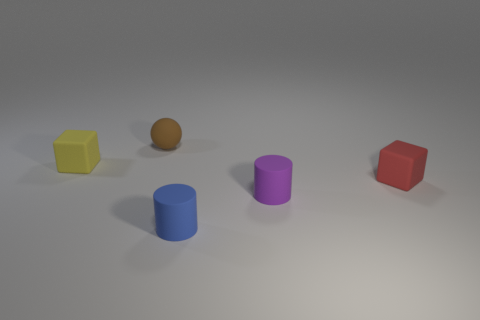There is a rubber object that is behind the block that is behind the block on the right side of the small yellow rubber block; what is its shape?
Ensure brevity in your answer.  Sphere. Is the brown object the same size as the red block?
Your response must be concise. Yes. How many objects are red objects or cylinders to the right of the tiny blue rubber thing?
Provide a succinct answer. 2. How many things are either tiny cubes that are left of the brown rubber ball or rubber blocks that are right of the yellow rubber cube?
Your answer should be very brief. 2. Are there any small purple cylinders behind the small purple rubber object?
Make the answer very short. No. There is a tiny block left of the matte cube that is on the right side of the small block on the left side of the tiny rubber sphere; what is its color?
Your answer should be compact. Yellow. Does the tiny yellow object have the same shape as the tiny red matte object?
Your answer should be compact. Yes. There is a sphere that is the same material as the small yellow thing; what color is it?
Your answer should be very brief. Brown. How many things are small blocks on the right side of the matte sphere or large gray blocks?
Make the answer very short. 1. There is a block on the right side of the tiny purple matte thing; what is its size?
Keep it short and to the point. Small. 